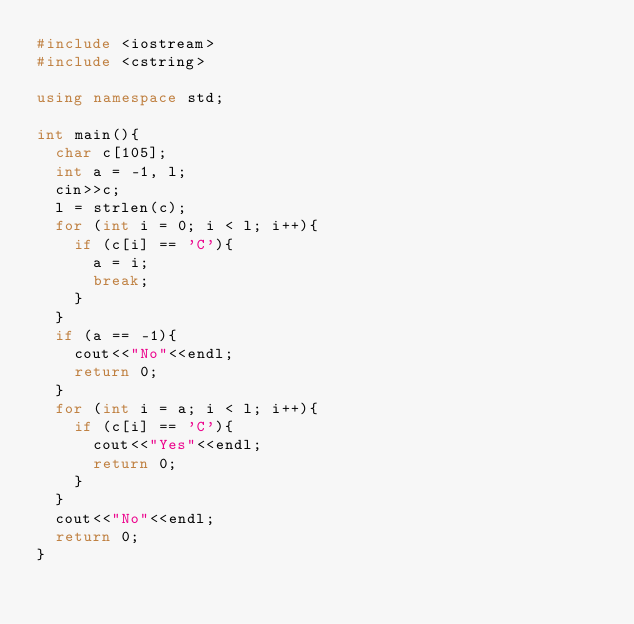Convert code to text. <code><loc_0><loc_0><loc_500><loc_500><_C++_>#include <iostream>
#include <cstring>

using namespace std;

int main(){
	char c[105];
	int a = -1, l;
	cin>>c;
	l = strlen(c);
	for (int i = 0; i < l; i++){
		if (c[i] == 'C'){
			a = i;
			break;
		}
	}
	if (a == -1){
		cout<<"No"<<endl;
		return 0;
	}
	for (int i = a; i < l; i++){
		if (c[i] == 'C'){
			cout<<"Yes"<<endl;
			return 0;
		}
	}
	cout<<"No"<<endl;
	return 0;
}</code> 